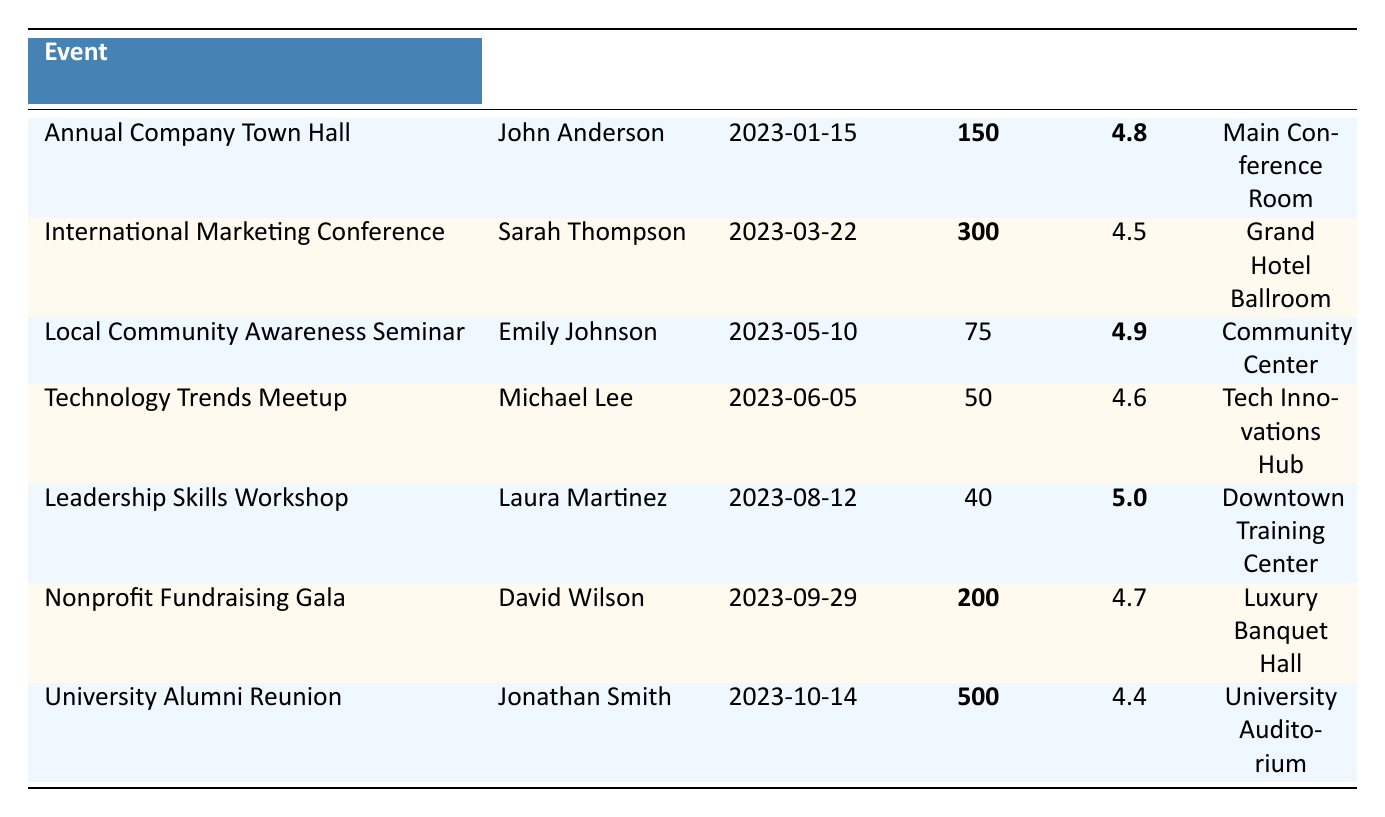What was the feedback score for the Leadership Skills Workshop? The feedback score for the Leadership Skills Workshop presented by Laura Martinez is listed in the table as 5.0.
Answer: 5.0 Who presented at the Annual Company Town Hall? According to the table, John Anderson is the presenter for the Annual Company Town Hall event.
Answer: John Anderson What date was the International Marketing Conference held? The table shows that the International Marketing Conference took place on March 22, 2023.
Answer: March 22, 2023 Which event had the smallest audience size? By checking the audience sizes listed for each event in the table, the Technology Trends Meetup had the smallest audience size of 50.
Answer: 50 What is the average feedback score of all the events listed? To find the average, sum the feedback scores (4.8 + 4.5 + 4.9 + 4.6 + 5.0 + 4.7 + 4.4 = 34.9) and divide by the number of events (7). The average score is 34.9 / 7 = 4.99.
Answer: 4.99 Did any presenter achieve a perfect feedback score? Looking at the feedback scores in the table, the Leadership Skills Workshop has a perfect feedback score of 5.0. Thus, yes, there was a presenter who achieved a perfect score.
Answer: Yes Which event had the highest audience size and what was the feedback score? The event with the highest audience size is the University Alumni Reunion with 500 attendees, and its feedback score is 4.4.
Answer: 500 attendees, feedback score 4.4 Compare the feedback scores of the Local Community Awareness Seminar and the Nonprofit Fundraising Gala. The Local Community Awareness Seminar has a feedback score of 4.9, while the Nonprofit Fundraising Gala has a score of 4.7. The Local Community Awareness Seminar received a higher score by 0.2 points.
Answer: Local Community Awareness Seminar: 4.9, Nonprofit Fundraising Gala: 4.7 How many events had a feedback score above 4.6? The events with feedback scores above 4.6 are the Annual Company Town Hall (4.8), Local Community Awareness Seminar (4.9), Leadership Skills Workshop (5.0), and Nonprofit Fundraising Gala (4.7), totaling 4 events.
Answer: 4 events Was there an event with a feedback score lower than 4.5? By reviewing the feedback scores, the lowest score is 4.4 for the University Alumni Reunion, which confirms that there is indeed an event with a score lower than 4.5.
Answer: Yes 